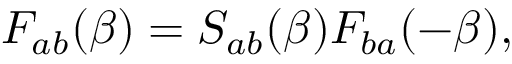<formula> <loc_0><loc_0><loc_500><loc_500>F _ { a b } ( \beta ) = S _ { a b } ( \beta ) F _ { b a } ( - \beta ) ,</formula> 